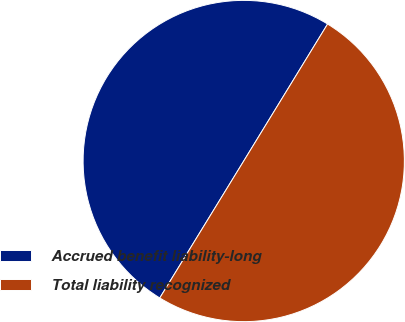Convert chart. <chart><loc_0><loc_0><loc_500><loc_500><pie_chart><fcel>Accrued benefit liability-long<fcel>Total liability recognized<nl><fcel>49.99%<fcel>50.01%<nl></chart> 